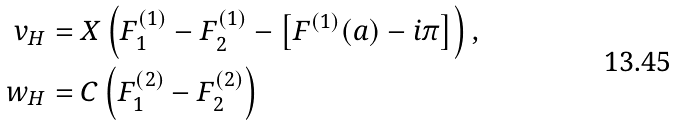<formula> <loc_0><loc_0><loc_500><loc_500>v _ { H } & = X \left ( F _ { 1 } ^ { ( 1 ) } - F _ { 2 } ^ { ( 1 ) } - \left [ F ^ { ( 1 ) } ( a ) - i \pi \right ] \right ) , \\ w _ { H } & = C \left ( F _ { 1 } ^ { ( 2 ) } - F _ { 2 } ^ { ( 2 ) } \right )</formula> 